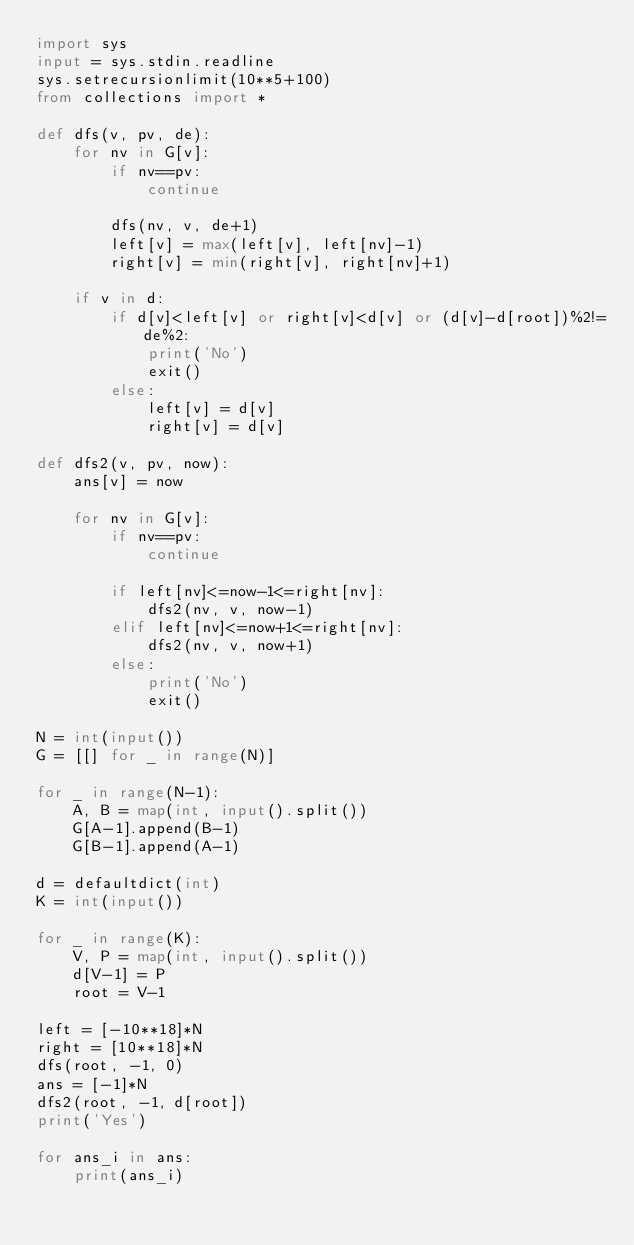<code> <loc_0><loc_0><loc_500><loc_500><_Python_>import sys
input = sys.stdin.readline
sys.setrecursionlimit(10**5+100)
from collections import *

def dfs(v, pv, de):
    for nv in G[v]:
        if nv==pv:
            continue
        
        dfs(nv, v, de+1)
        left[v] = max(left[v], left[nv]-1)
        right[v] = min(right[v], right[nv]+1)
    
    if v in d:
        if d[v]<left[v] or right[v]<d[v] or (d[v]-d[root])%2!=de%2:
            print('No')
            exit()
        else:
            left[v] = d[v]
            right[v] = d[v]
    
def dfs2(v, pv, now):
    ans[v] = now
    
    for nv in G[v]:
        if nv==pv:
            continue
        
        if left[nv]<=now-1<=right[nv]:
            dfs2(nv, v, now-1)
        elif left[nv]<=now+1<=right[nv]:
            dfs2(nv, v, now+1)
        else:
            print('No')
            exit()
    
N = int(input())
G = [[] for _ in range(N)]

for _ in range(N-1):
    A, B = map(int, input().split())
    G[A-1].append(B-1)
    G[B-1].append(A-1)

d = defaultdict(int)
K = int(input())

for _ in range(K):
    V, P = map(int, input().split())
    d[V-1] = P
    root = V-1

left = [-10**18]*N
right = [10**18]*N
dfs(root, -1, 0)
ans = [-1]*N
dfs2(root, -1, d[root])
print('Yes')

for ans_i in ans:
    print(ans_i)
</code> 